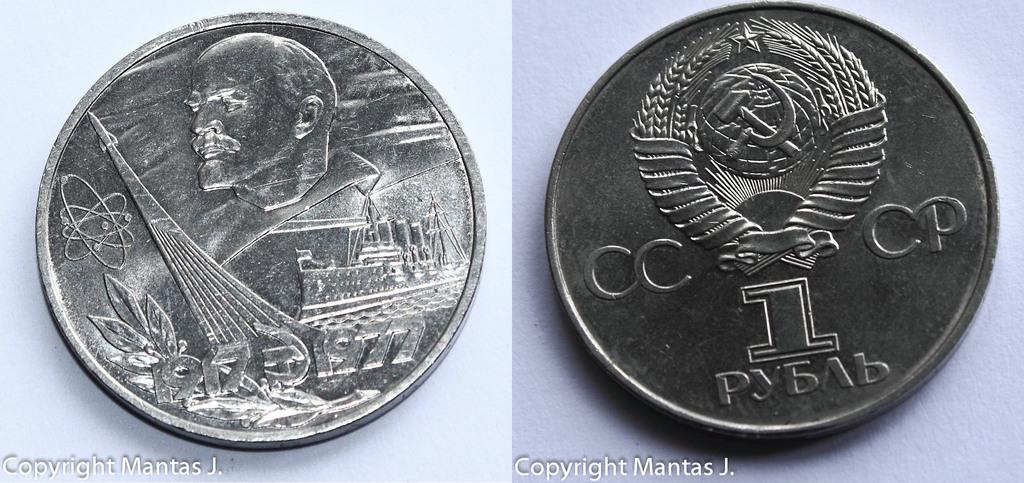What four letters are on the coin on the right?
Make the answer very short. Cccp. 